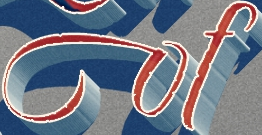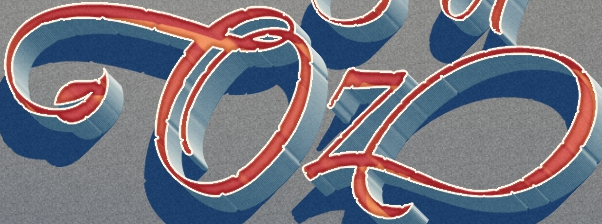Identify the words shown in these images in order, separated by a semicolon. of; Oz 